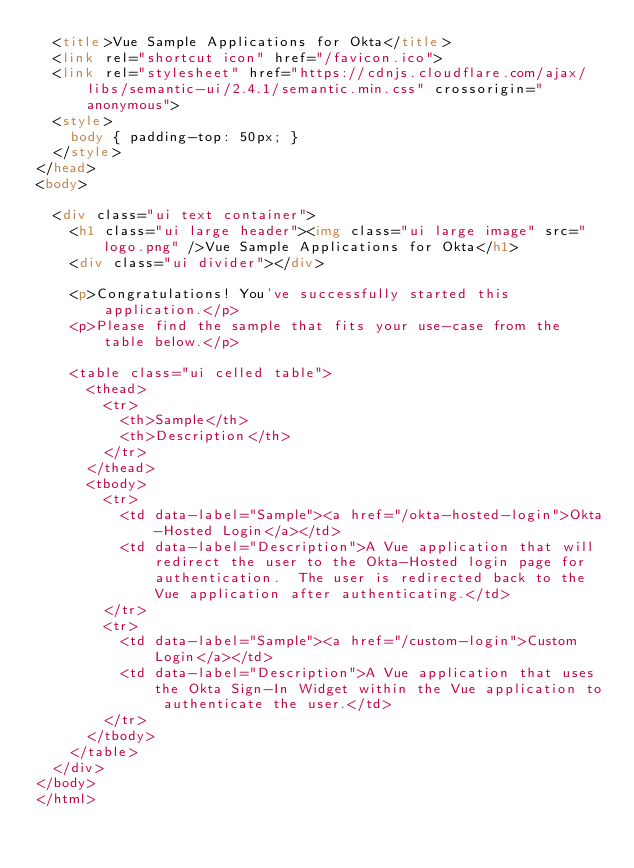Convert code to text. <code><loc_0><loc_0><loc_500><loc_500><_HTML_>  <title>Vue Sample Applications for Okta</title>
  <link rel="shortcut icon" href="/favicon.ico">
  <link rel="stylesheet" href="https://cdnjs.cloudflare.com/ajax/libs/semantic-ui/2.4.1/semantic.min.css" crossorigin="anonymous">
  <style>
    body { padding-top: 50px; }
  </style>
</head>
<body>

  <div class="ui text container">
    <h1 class="ui large header"><img class="ui large image" src="logo.png" />Vue Sample Applications for Okta</h1>
    <div class="ui divider"></div>

    <p>Congratulations! You've successfully started this application.</p>
    <p>Please find the sample that fits your use-case from the table below.</p>

    <table class="ui celled table">
      <thead>
        <tr>
          <th>Sample</th>
          <th>Description</th>
        </tr>
      </thead>
      <tbody>
        <tr>
          <td data-label="Sample"><a href="/okta-hosted-login">Okta-Hosted Login</a></td>
          <td data-label="Description">A Vue application that will redirect the user to the Okta-Hosted login page for authentication.  The user is redirected back to the Vue application after authenticating.</td>
        </tr>
        <tr>
          <td data-label="Sample"><a href="/custom-login">Custom Login</a></td>
          <td data-label="Description">A Vue application that uses the Okta Sign-In Widget within the Vue application to authenticate the user.</td>
        </tr>
      </tbody>
    </table>
  </div>
</body>
</html>
</code> 